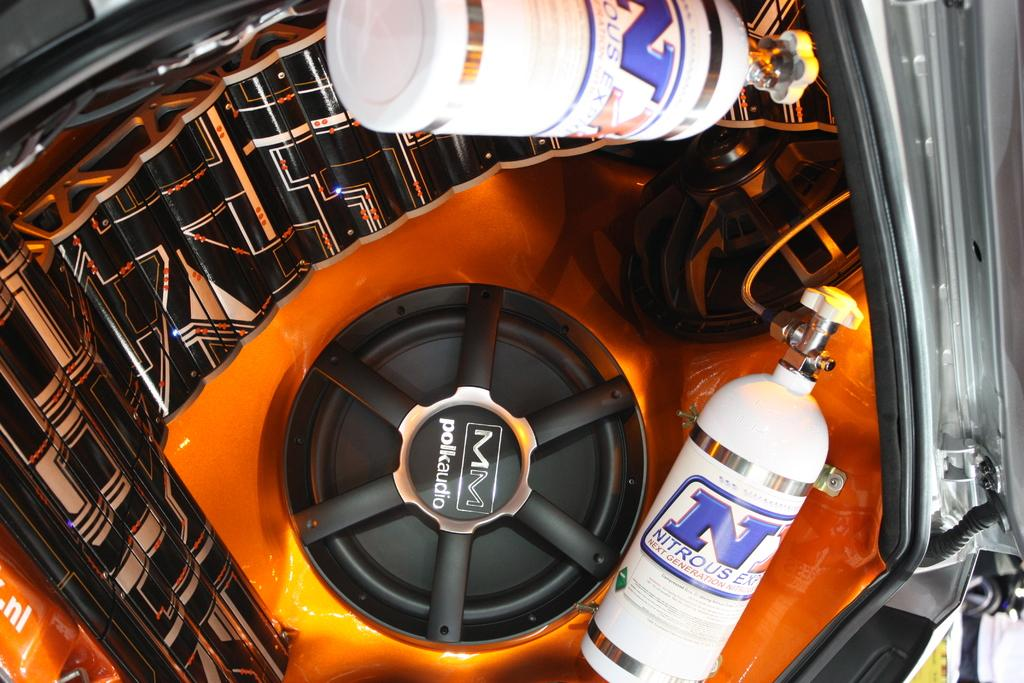What is the main subject of the image? The main subject of the image is a car's noise system. What components are visible in the image? There are speakers and cylinders in the image. Can you describe the black and white object in the image? There is a black and white object in the image, but its specific details are not clear from the provided facts. What type of ring can be seen on the cylinder in the image? There is no ring present on the cylinder in the image. What reason might the car's noise system be in the image? The reason for the car's noise system being in the image is not clear from the provided facts. 